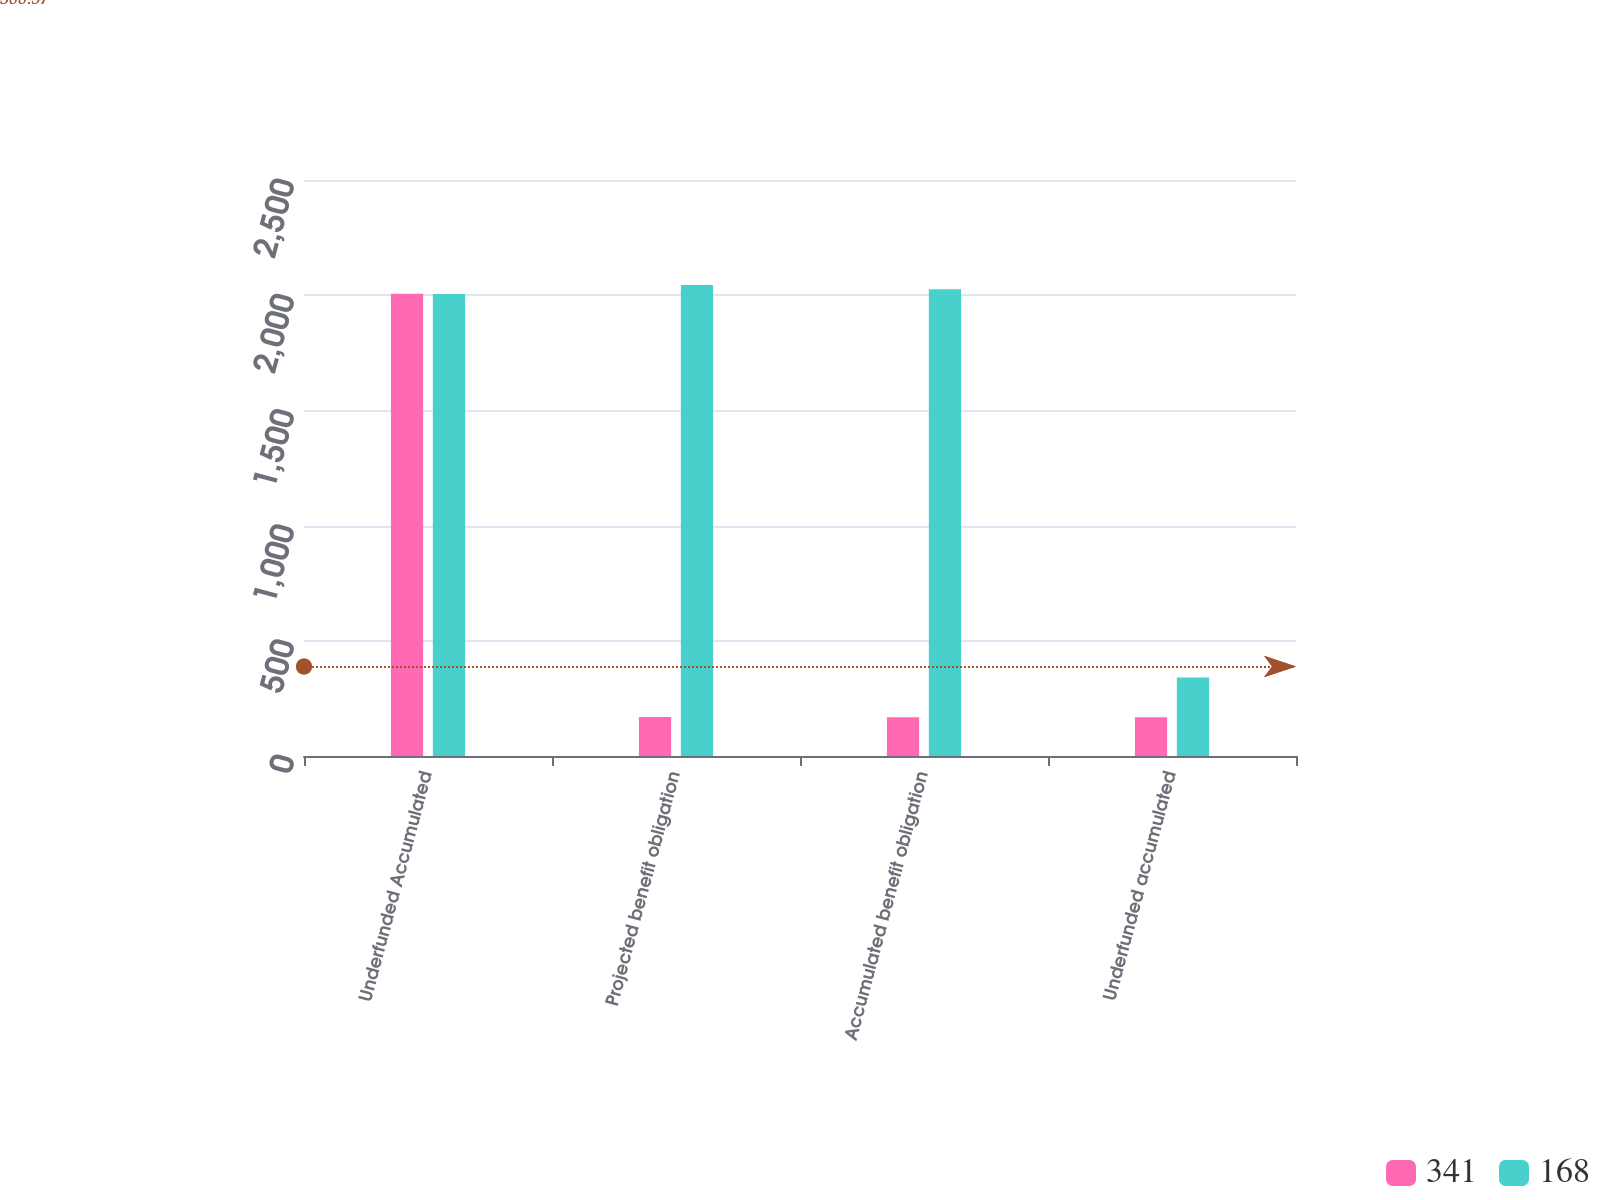Convert chart to OTSL. <chart><loc_0><loc_0><loc_500><loc_500><stacked_bar_chart><ecel><fcel>Underfunded Accumulated<fcel>Projected benefit obligation<fcel>Accumulated benefit obligation<fcel>Underfunded accumulated<nl><fcel>341<fcel>2006<fcel>169<fcel>168<fcel>168<nl><fcel>168<fcel>2005<fcel>2044<fcel>2026<fcel>341<nl></chart> 